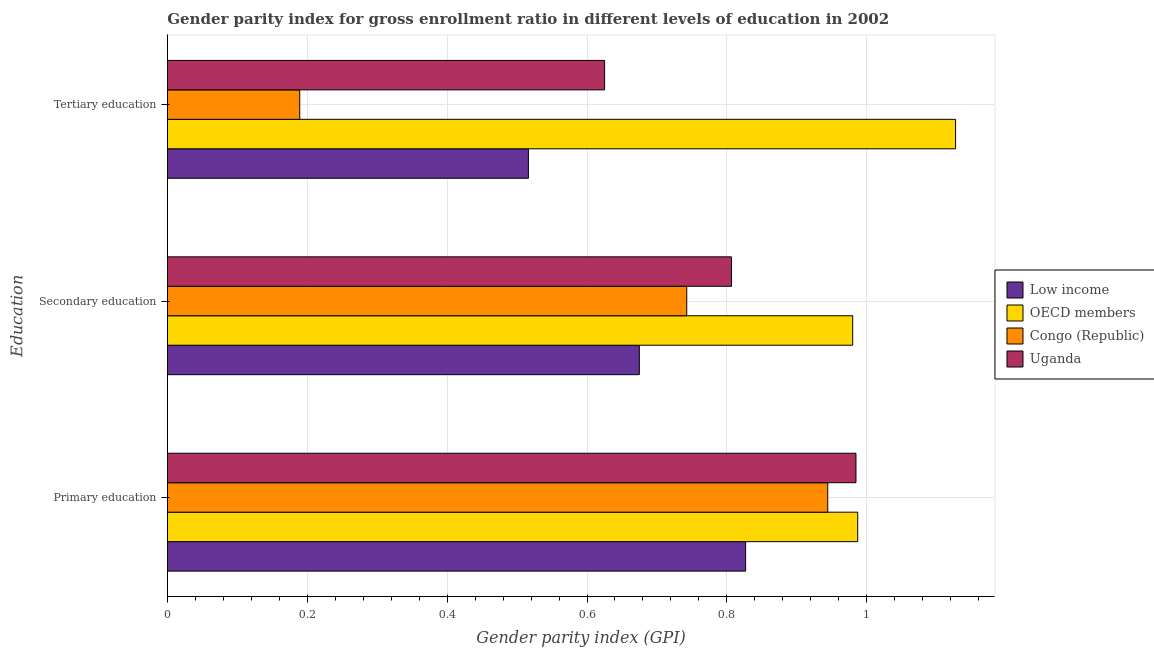How many different coloured bars are there?
Your answer should be compact. 4. How many bars are there on the 3rd tick from the bottom?
Provide a succinct answer. 4. What is the label of the 1st group of bars from the top?
Your answer should be very brief. Tertiary education. What is the gender parity index in tertiary education in Congo (Republic)?
Your answer should be very brief. 0.19. Across all countries, what is the maximum gender parity index in tertiary education?
Your answer should be compact. 1.13. Across all countries, what is the minimum gender parity index in tertiary education?
Make the answer very short. 0.19. In which country was the gender parity index in tertiary education maximum?
Give a very brief answer. OECD members. In which country was the gender parity index in secondary education minimum?
Give a very brief answer. Low income. What is the total gender parity index in primary education in the graph?
Provide a succinct answer. 3.74. What is the difference between the gender parity index in primary education in OECD members and that in Congo (Republic)?
Offer a very short reply. 0.04. What is the difference between the gender parity index in secondary education in Low income and the gender parity index in tertiary education in Congo (Republic)?
Ensure brevity in your answer.  0.49. What is the average gender parity index in primary education per country?
Offer a very short reply. 0.94. What is the difference between the gender parity index in tertiary education and gender parity index in secondary education in OECD members?
Provide a succinct answer. 0.15. In how many countries, is the gender parity index in secondary education greater than 0.08 ?
Provide a short and direct response. 4. What is the ratio of the gender parity index in tertiary education in Congo (Republic) to that in OECD members?
Offer a terse response. 0.17. Is the difference between the gender parity index in tertiary education in Congo (Republic) and Uganda greater than the difference between the gender parity index in secondary education in Congo (Republic) and Uganda?
Your response must be concise. No. What is the difference between the highest and the second highest gender parity index in secondary education?
Give a very brief answer. 0.17. What is the difference between the highest and the lowest gender parity index in secondary education?
Your response must be concise. 0.31. What does the 3rd bar from the top in Primary education represents?
Your answer should be compact. OECD members. Does the graph contain any zero values?
Keep it short and to the point. No. Does the graph contain grids?
Your answer should be compact. Yes. Where does the legend appear in the graph?
Provide a short and direct response. Center right. How are the legend labels stacked?
Provide a short and direct response. Vertical. What is the title of the graph?
Keep it short and to the point. Gender parity index for gross enrollment ratio in different levels of education in 2002. What is the label or title of the X-axis?
Your answer should be compact. Gender parity index (GPI). What is the label or title of the Y-axis?
Offer a very short reply. Education. What is the Gender parity index (GPI) of Low income in Primary education?
Your answer should be very brief. 0.83. What is the Gender parity index (GPI) of OECD members in Primary education?
Offer a terse response. 0.99. What is the Gender parity index (GPI) in Congo (Republic) in Primary education?
Make the answer very short. 0.94. What is the Gender parity index (GPI) of Uganda in Primary education?
Your response must be concise. 0.98. What is the Gender parity index (GPI) in Low income in Secondary education?
Provide a succinct answer. 0.67. What is the Gender parity index (GPI) in OECD members in Secondary education?
Offer a very short reply. 0.98. What is the Gender parity index (GPI) in Congo (Republic) in Secondary education?
Give a very brief answer. 0.74. What is the Gender parity index (GPI) of Uganda in Secondary education?
Keep it short and to the point. 0.81. What is the Gender parity index (GPI) in Low income in Tertiary education?
Your answer should be compact. 0.52. What is the Gender parity index (GPI) of OECD members in Tertiary education?
Provide a short and direct response. 1.13. What is the Gender parity index (GPI) in Congo (Republic) in Tertiary education?
Your answer should be compact. 0.19. What is the Gender parity index (GPI) of Uganda in Tertiary education?
Provide a short and direct response. 0.63. Across all Education, what is the maximum Gender parity index (GPI) of Low income?
Make the answer very short. 0.83. Across all Education, what is the maximum Gender parity index (GPI) of OECD members?
Your answer should be compact. 1.13. Across all Education, what is the maximum Gender parity index (GPI) of Congo (Republic)?
Keep it short and to the point. 0.94. Across all Education, what is the maximum Gender parity index (GPI) in Uganda?
Your answer should be very brief. 0.98. Across all Education, what is the minimum Gender parity index (GPI) in Low income?
Ensure brevity in your answer.  0.52. Across all Education, what is the minimum Gender parity index (GPI) of OECD members?
Provide a succinct answer. 0.98. Across all Education, what is the minimum Gender parity index (GPI) in Congo (Republic)?
Your response must be concise. 0.19. Across all Education, what is the minimum Gender parity index (GPI) of Uganda?
Provide a short and direct response. 0.63. What is the total Gender parity index (GPI) in Low income in the graph?
Your answer should be compact. 2.02. What is the total Gender parity index (GPI) in OECD members in the graph?
Ensure brevity in your answer.  3.09. What is the total Gender parity index (GPI) of Congo (Republic) in the graph?
Offer a terse response. 1.88. What is the total Gender parity index (GPI) in Uganda in the graph?
Provide a short and direct response. 2.42. What is the difference between the Gender parity index (GPI) of Low income in Primary education and that in Secondary education?
Offer a terse response. 0.15. What is the difference between the Gender parity index (GPI) of OECD members in Primary education and that in Secondary education?
Keep it short and to the point. 0.01. What is the difference between the Gender parity index (GPI) in Congo (Republic) in Primary education and that in Secondary education?
Your answer should be compact. 0.2. What is the difference between the Gender parity index (GPI) in Uganda in Primary education and that in Secondary education?
Offer a very short reply. 0.18. What is the difference between the Gender parity index (GPI) of Low income in Primary education and that in Tertiary education?
Your answer should be very brief. 0.31. What is the difference between the Gender parity index (GPI) of OECD members in Primary education and that in Tertiary education?
Keep it short and to the point. -0.14. What is the difference between the Gender parity index (GPI) in Congo (Republic) in Primary education and that in Tertiary education?
Give a very brief answer. 0.76. What is the difference between the Gender parity index (GPI) in Uganda in Primary education and that in Tertiary education?
Offer a terse response. 0.36. What is the difference between the Gender parity index (GPI) of Low income in Secondary education and that in Tertiary education?
Keep it short and to the point. 0.16. What is the difference between the Gender parity index (GPI) of OECD members in Secondary education and that in Tertiary education?
Ensure brevity in your answer.  -0.15. What is the difference between the Gender parity index (GPI) in Congo (Republic) in Secondary education and that in Tertiary education?
Give a very brief answer. 0.55. What is the difference between the Gender parity index (GPI) in Uganda in Secondary education and that in Tertiary education?
Give a very brief answer. 0.18. What is the difference between the Gender parity index (GPI) of Low income in Primary education and the Gender parity index (GPI) of OECD members in Secondary education?
Offer a very short reply. -0.15. What is the difference between the Gender parity index (GPI) of Low income in Primary education and the Gender parity index (GPI) of Congo (Republic) in Secondary education?
Your response must be concise. 0.08. What is the difference between the Gender parity index (GPI) in Low income in Primary education and the Gender parity index (GPI) in Uganda in Secondary education?
Make the answer very short. 0.02. What is the difference between the Gender parity index (GPI) of OECD members in Primary education and the Gender parity index (GPI) of Congo (Republic) in Secondary education?
Give a very brief answer. 0.24. What is the difference between the Gender parity index (GPI) of OECD members in Primary education and the Gender parity index (GPI) of Uganda in Secondary education?
Give a very brief answer. 0.18. What is the difference between the Gender parity index (GPI) of Congo (Republic) in Primary education and the Gender parity index (GPI) of Uganda in Secondary education?
Ensure brevity in your answer.  0.14. What is the difference between the Gender parity index (GPI) of Low income in Primary education and the Gender parity index (GPI) of OECD members in Tertiary education?
Your answer should be very brief. -0.3. What is the difference between the Gender parity index (GPI) in Low income in Primary education and the Gender parity index (GPI) in Congo (Republic) in Tertiary education?
Your answer should be very brief. 0.64. What is the difference between the Gender parity index (GPI) in Low income in Primary education and the Gender parity index (GPI) in Uganda in Tertiary education?
Your response must be concise. 0.2. What is the difference between the Gender parity index (GPI) of OECD members in Primary education and the Gender parity index (GPI) of Congo (Republic) in Tertiary education?
Ensure brevity in your answer.  0.8. What is the difference between the Gender parity index (GPI) in OECD members in Primary education and the Gender parity index (GPI) in Uganda in Tertiary education?
Provide a succinct answer. 0.36. What is the difference between the Gender parity index (GPI) in Congo (Republic) in Primary education and the Gender parity index (GPI) in Uganda in Tertiary education?
Ensure brevity in your answer.  0.32. What is the difference between the Gender parity index (GPI) in Low income in Secondary education and the Gender parity index (GPI) in OECD members in Tertiary education?
Make the answer very short. -0.45. What is the difference between the Gender parity index (GPI) in Low income in Secondary education and the Gender parity index (GPI) in Congo (Republic) in Tertiary education?
Your answer should be very brief. 0.49. What is the difference between the Gender parity index (GPI) of Low income in Secondary education and the Gender parity index (GPI) of Uganda in Tertiary education?
Your answer should be compact. 0.05. What is the difference between the Gender parity index (GPI) in OECD members in Secondary education and the Gender parity index (GPI) in Congo (Republic) in Tertiary education?
Make the answer very short. 0.79. What is the difference between the Gender parity index (GPI) of OECD members in Secondary education and the Gender parity index (GPI) of Uganda in Tertiary education?
Offer a terse response. 0.35. What is the difference between the Gender parity index (GPI) of Congo (Republic) in Secondary education and the Gender parity index (GPI) of Uganda in Tertiary education?
Ensure brevity in your answer.  0.12. What is the average Gender parity index (GPI) of Low income per Education?
Give a very brief answer. 0.67. What is the average Gender parity index (GPI) in OECD members per Education?
Make the answer very short. 1.03. What is the average Gender parity index (GPI) in Congo (Republic) per Education?
Your answer should be compact. 0.63. What is the average Gender parity index (GPI) of Uganda per Education?
Provide a short and direct response. 0.81. What is the difference between the Gender parity index (GPI) in Low income and Gender parity index (GPI) in OECD members in Primary education?
Offer a terse response. -0.16. What is the difference between the Gender parity index (GPI) in Low income and Gender parity index (GPI) in Congo (Republic) in Primary education?
Your answer should be compact. -0.12. What is the difference between the Gender parity index (GPI) of Low income and Gender parity index (GPI) of Uganda in Primary education?
Offer a very short reply. -0.16. What is the difference between the Gender parity index (GPI) of OECD members and Gender parity index (GPI) of Congo (Republic) in Primary education?
Make the answer very short. 0.04. What is the difference between the Gender parity index (GPI) of OECD members and Gender parity index (GPI) of Uganda in Primary education?
Offer a terse response. 0. What is the difference between the Gender parity index (GPI) of Congo (Republic) and Gender parity index (GPI) of Uganda in Primary education?
Keep it short and to the point. -0.04. What is the difference between the Gender parity index (GPI) of Low income and Gender parity index (GPI) of OECD members in Secondary education?
Make the answer very short. -0.31. What is the difference between the Gender parity index (GPI) in Low income and Gender parity index (GPI) in Congo (Republic) in Secondary education?
Offer a terse response. -0.07. What is the difference between the Gender parity index (GPI) of Low income and Gender parity index (GPI) of Uganda in Secondary education?
Provide a succinct answer. -0.13. What is the difference between the Gender parity index (GPI) in OECD members and Gender parity index (GPI) in Congo (Republic) in Secondary education?
Ensure brevity in your answer.  0.24. What is the difference between the Gender parity index (GPI) of OECD members and Gender parity index (GPI) of Uganda in Secondary education?
Ensure brevity in your answer.  0.17. What is the difference between the Gender parity index (GPI) of Congo (Republic) and Gender parity index (GPI) of Uganda in Secondary education?
Ensure brevity in your answer.  -0.06. What is the difference between the Gender parity index (GPI) in Low income and Gender parity index (GPI) in OECD members in Tertiary education?
Make the answer very short. -0.61. What is the difference between the Gender parity index (GPI) in Low income and Gender parity index (GPI) in Congo (Republic) in Tertiary education?
Your response must be concise. 0.33. What is the difference between the Gender parity index (GPI) of Low income and Gender parity index (GPI) of Uganda in Tertiary education?
Your answer should be very brief. -0.11. What is the difference between the Gender parity index (GPI) in OECD members and Gender parity index (GPI) in Congo (Republic) in Tertiary education?
Provide a succinct answer. 0.94. What is the difference between the Gender parity index (GPI) of OECD members and Gender parity index (GPI) of Uganda in Tertiary education?
Make the answer very short. 0.5. What is the difference between the Gender parity index (GPI) in Congo (Republic) and Gender parity index (GPI) in Uganda in Tertiary education?
Provide a succinct answer. -0.44. What is the ratio of the Gender parity index (GPI) of Low income in Primary education to that in Secondary education?
Give a very brief answer. 1.23. What is the ratio of the Gender parity index (GPI) of OECD members in Primary education to that in Secondary education?
Provide a short and direct response. 1.01. What is the ratio of the Gender parity index (GPI) in Congo (Republic) in Primary education to that in Secondary education?
Your answer should be compact. 1.27. What is the ratio of the Gender parity index (GPI) in Uganda in Primary education to that in Secondary education?
Offer a very short reply. 1.22. What is the ratio of the Gender parity index (GPI) of Low income in Primary education to that in Tertiary education?
Give a very brief answer. 1.6. What is the ratio of the Gender parity index (GPI) of OECD members in Primary education to that in Tertiary education?
Provide a short and direct response. 0.88. What is the ratio of the Gender parity index (GPI) in Congo (Republic) in Primary education to that in Tertiary education?
Keep it short and to the point. 4.99. What is the ratio of the Gender parity index (GPI) of Uganda in Primary education to that in Tertiary education?
Keep it short and to the point. 1.57. What is the ratio of the Gender parity index (GPI) of Low income in Secondary education to that in Tertiary education?
Keep it short and to the point. 1.31. What is the ratio of the Gender parity index (GPI) in OECD members in Secondary education to that in Tertiary education?
Provide a succinct answer. 0.87. What is the ratio of the Gender parity index (GPI) in Congo (Republic) in Secondary education to that in Tertiary education?
Your answer should be very brief. 3.92. What is the ratio of the Gender parity index (GPI) in Uganda in Secondary education to that in Tertiary education?
Keep it short and to the point. 1.29. What is the difference between the highest and the second highest Gender parity index (GPI) of Low income?
Your response must be concise. 0.15. What is the difference between the highest and the second highest Gender parity index (GPI) of OECD members?
Your answer should be compact. 0.14. What is the difference between the highest and the second highest Gender parity index (GPI) in Congo (Republic)?
Your answer should be very brief. 0.2. What is the difference between the highest and the second highest Gender parity index (GPI) in Uganda?
Offer a terse response. 0.18. What is the difference between the highest and the lowest Gender parity index (GPI) of Low income?
Make the answer very short. 0.31. What is the difference between the highest and the lowest Gender parity index (GPI) of OECD members?
Provide a short and direct response. 0.15. What is the difference between the highest and the lowest Gender parity index (GPI) in Congo (Republic)?
Make the answer very short. 0.76. What is the difference between the highest and the lowest Gender parity index (GPI) of Uganda?
Ensure brevity in your answer.  0.36. 